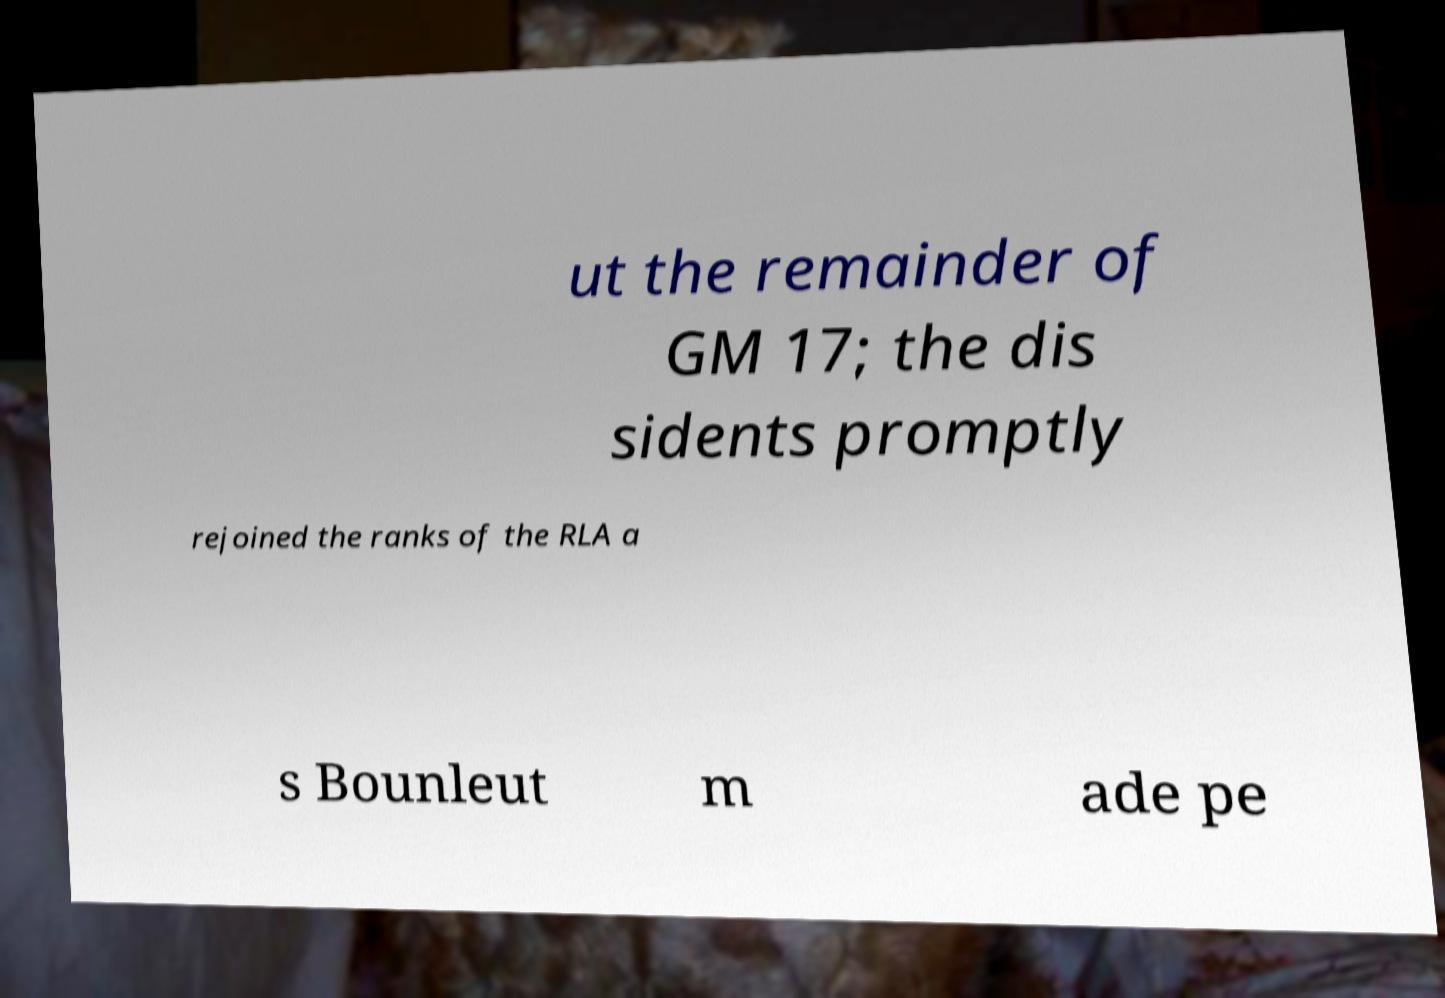Please read and relay the text visible in this image. What does it say? ut the remainder of GM 17; the dis sidents promptly rejoined the ranks of the RLA a s Bounleut m ade pe 